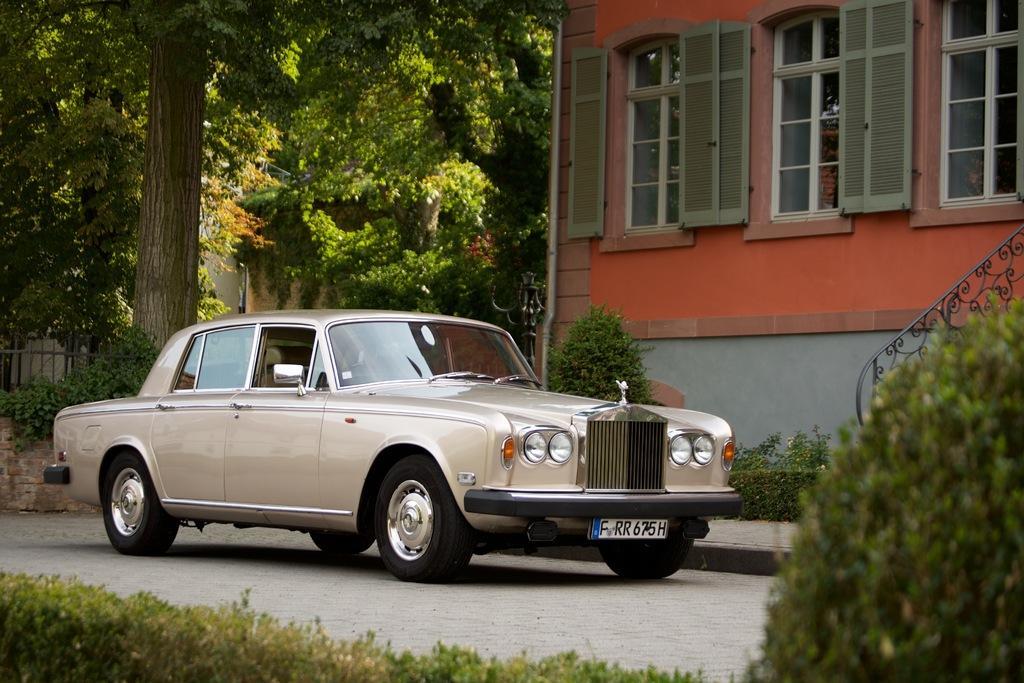Could you give a brief overview of what you see in this image? In the picture I can see a car and there is a building in the right corner and there are few trees,a fence and a building in the background. 